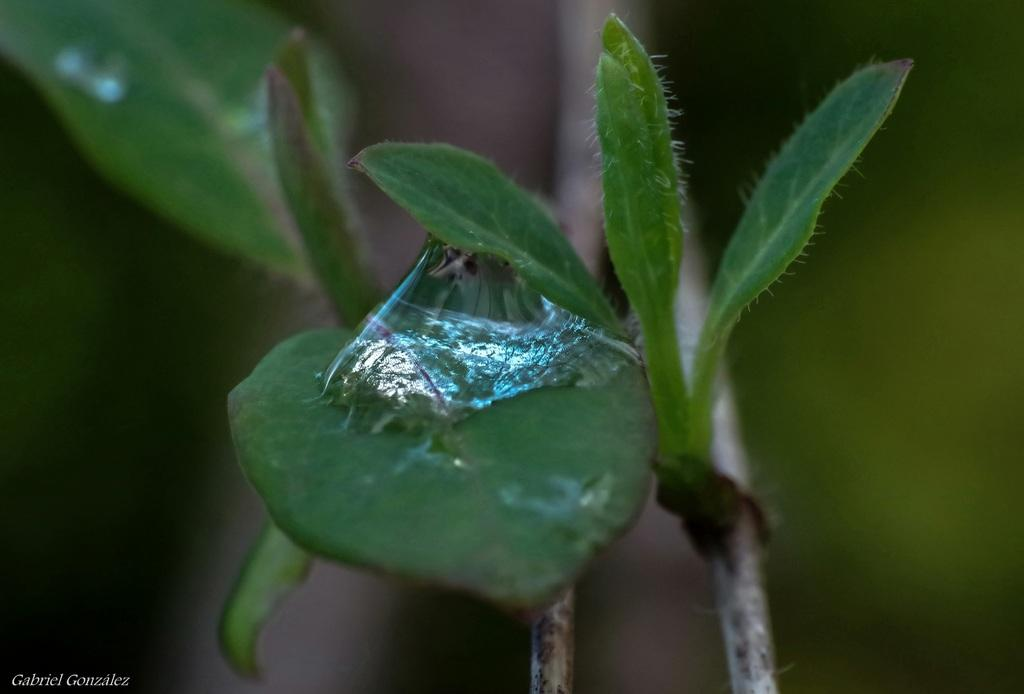What is on the leaf in the image? There is a sticky substance on a leaf in the image. How many leaves can be seen in the image? There are multiple leaves visible in the image. What else can be seen in the image besides leaves? Stems are visible in the image. Can you describe the background of the image? The background of the image is blurry. Is there any text present in the image? Yes, there is some text in the bottom left corner of the image. What type of boot is shown in the image? There is no boot present in the image. What is the title of the image? The image does not have a title. 